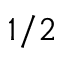<formula> <loc_0><loc_0><loc_500><loc_500>1 / 2</formula> 